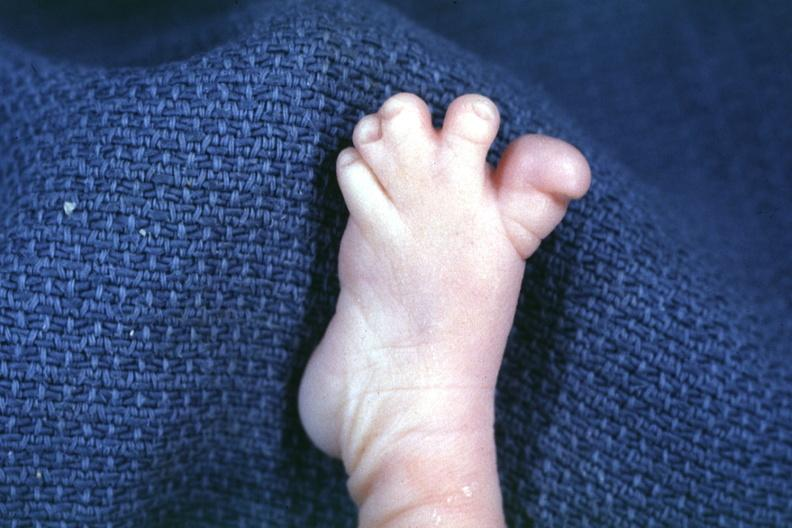re extremities present?
Answer the question using a single word or phrase. Yes 